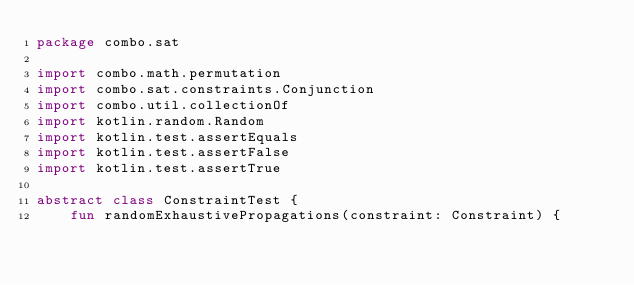Convert code to text. <code><loc_0><loc_0><loc_500><loc_500><_Kotlin_>package combo.sat

import combo.math.permutation
import combo.sat.constraints.Conjunction
import combo.util.collectionOf
import kotlin.random.Random
import kotlin.test.assertEquals
import kotlin.test.assertFalse
import kotlin.test.assertTrue

abstract class ConstraintTest {
    fun randomExhaustivePropagations(constraint: Constraint) {</code> 